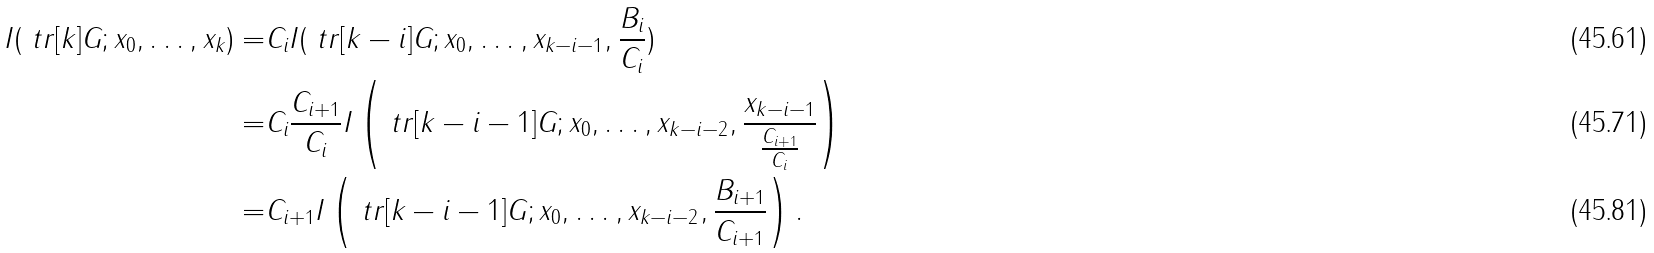Convert formula to latex. <formula><loc_0><loc_0><loc_500><loc_500>I ( \ t r [ k ] G ; x _ { 0 } , \dots , x _ { k } ) = & C _ { i } I ( \ t r [ k - i ] G ; x _ { 0 } , \dots , x _ { k - i - 1 } , \frac { B _ { i } } { C _ { i } } ) \\ = & C _ { i } \frac { C _ { i + 1 } } { C _ { i } } I \left ( \ t r [ k - i - 1 ] G ; x _ { 0 } , \dots , x _ { k - i - 2 } , \frac { x _ { k - i - 1 } } { \frac { C _ { i + 1 } } { C _ { i } } } \right ) \\ = & C _ { i + 1 } I \left ( \ t r [ k - i - 1 ] G ; x _ { 0 } , \dots , x _ { k - i - 2 } , \frac { B _ { i + 1 } } { C _ { i + 1 } } \right ) .</formula> 